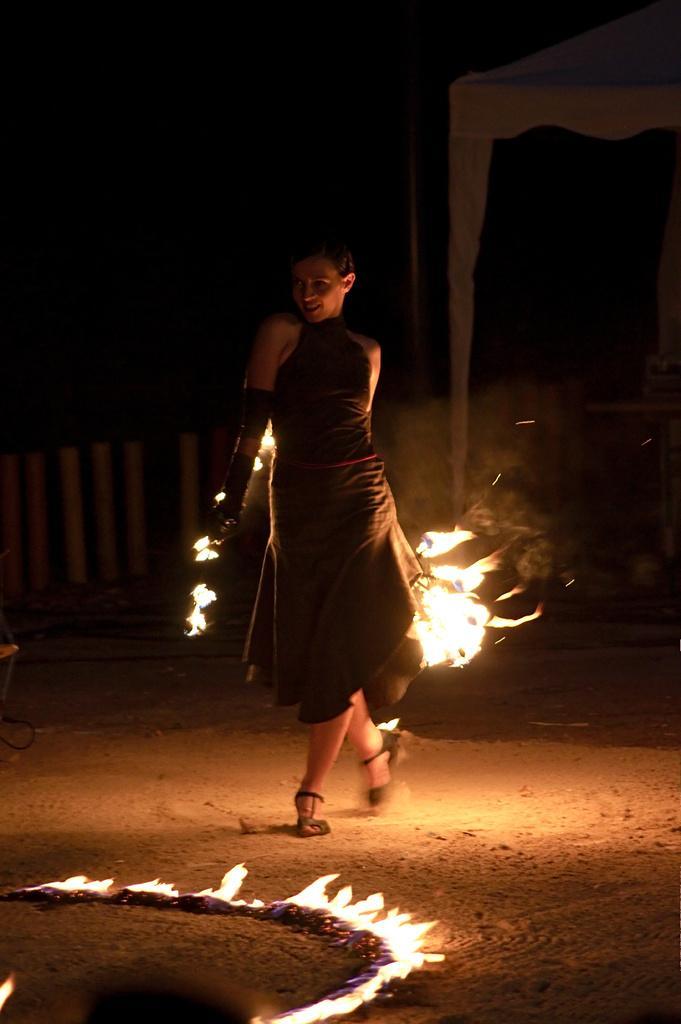Describe this image in one or two sentences. In this image we can see a woman is performing fire dance. She is wearing black color dress. We can see fire on the land at the bottom of the image. We can see fencing and tent in the background of the image. 